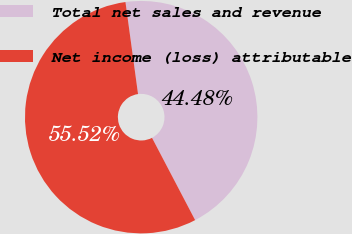Convert chart. <chart><loc_0><loc_0><loc_500><loc_500><pie_chart><fcel>Total net sales and revenue<fcel>Net income (loss) attributable<nl><fcel>44.48%<fcel>55.52%<nl></chart> 